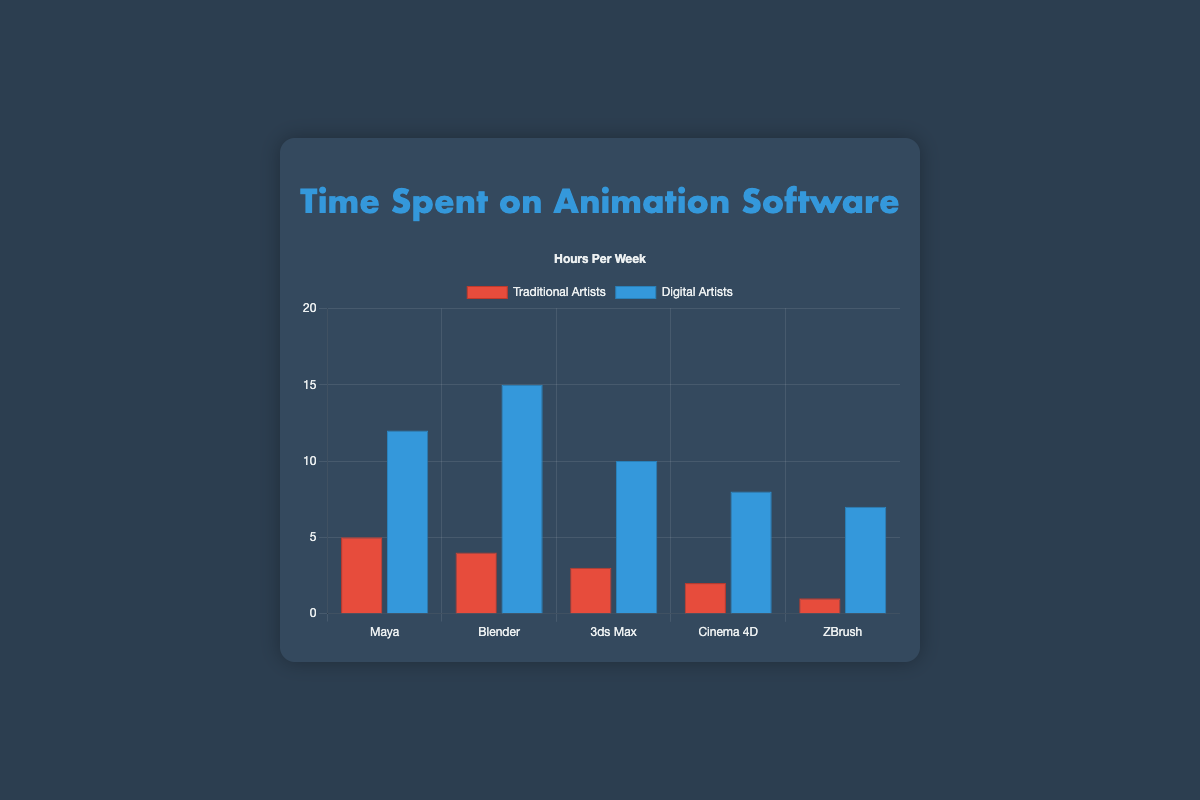What's the difference in time spent on Blender between Traditional Artists and Digital Artists? The time spent by Traditional Artists on Blender is 4 hours per week, while Digital Artists spend 15 hours per week. The difference is 15 - 4 = 11 hours.
Answer: 11 hours Which software shows the highest time spent by Digital Artists? By comparing all the values for Digital Artists, Blender has the highest usage at 15 hours per week.
Answer: Blender Which group spends more time on Maya and by how much? Traditional Artists spend 5 hours per week on Maya, while Digital Artists spend 12 hours per week on Maya. The difference is 12 - 5 = 7 hours, with Digital Artists spending more.
Answer: Digital Artists, 7 hours What is the total time spent on 3ds Max by both Traditional and Digital Artists combined? Traditional Artists spend 3 hours, and Digital Artists spend 10 hours on 3ds Max. The total time combined is 3 + 10 = 13 hours.
Answer: 13 hours How much more time do Digital Artists spend on ZBrush compared to Traditional Artists? Traditional Artists spend 1 hour on ZBrush, while Digital Artists spend 7 hours. The difference is 7 - 1 = 6 hours.
Answer: 6 hours Rank the softwares based on the total time spent by both groups combined from highest to lowest. Compute total times for both groups combined: Maya (5 + 12 = 17), Blender (4 + 15 = 19), 3ds Max (3 + 10 = 13), Cinema 4D (2 + 8 = 10), ZBrush (1 + 7 = 8). Ranking from highest to lowest: Blender, Maya, 3ds Max, Cinema 4D, ZBrush.
Answer: Blender > Maya > 3ds Max > Cinema 4D > ZBrush Which software has the smallest difference in usage time between the two groups? Calculate the differences: Maya (7), Blender (11), 3ds Max (7), Cinema 4D (6), ZBrush (6). The smallest difference is 6 hours for both Cinema 4D and ZBrush.
Answer: Cinema 4D and ZBrush Is there any software that Traditional Artists use more than Digital Artists? By looking at the data, for all the softwares, Digital Artists spend more time than Traditional Artists.
Answer: No 